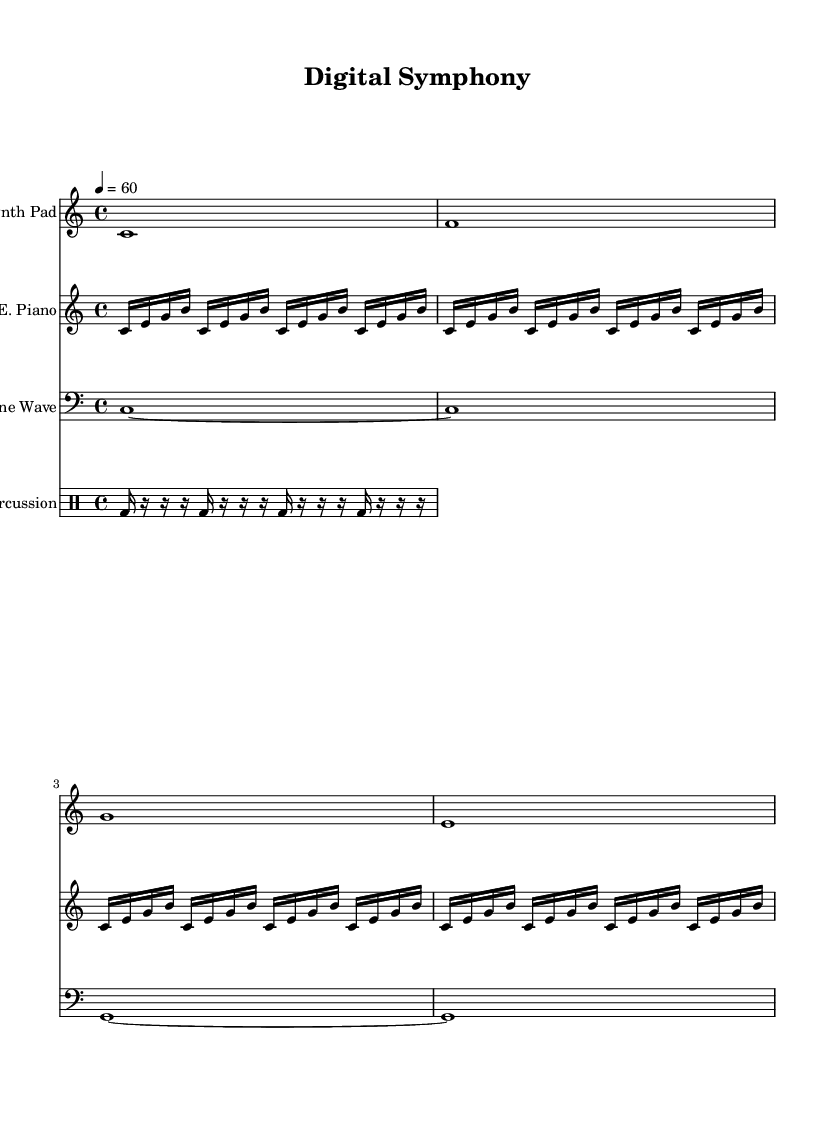What is the key signature of this music? The key signature is C major, which has no sharps or flats.
Answer: C major What is the time signature of this piece? The time signature is indicated at the beginning of the score as 4/4, which means there are four beats in each measure.
Answer: 4/4 What is the tempo marking for this composition? The tempo marking indicates that the piece should be played at a speed of 60 beats per minute, as shown by the tempo of "4 = 60".
Answer: 60 How many measures are in the synth pad part? The synth pad consists of four measures, each represented by a vertical bar line. The full score displays four distinct segments for synth sound.
Answer: Four What kind of instrument is represented in the second staff? The second staff is labeled "E. Piano", indicating that it is meant for an electric piano as shown at the beginning of the staff.
Answer: Electric Piano What rhythmic pattern do the percussion instruments primarily play? The percussion part is based on a repeating pattern of bass drums and rests, where each section contains a triplet of rests after a bass drum hit.
Answer: Bass drum and rests How does the sine wave contribute to the overall soundscape? The sine wave section is sustained over longer durations and provides a foundation or drone-like support in the music, creating an ambient feel by keeping certain notes fixed.
Answer: Drone-like support 